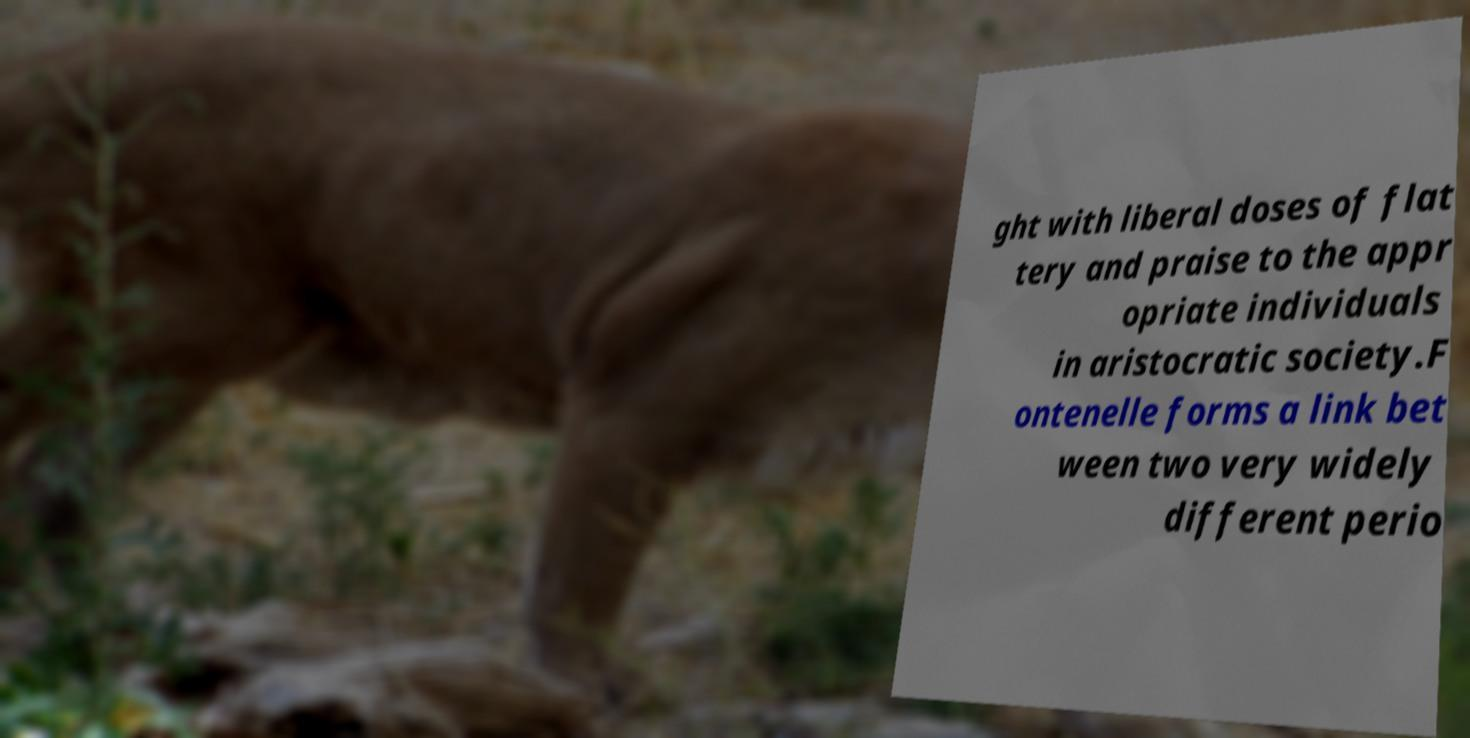Could you extract and type out the text from this image? ght with liberal doses of flat tery and praise to the appr opriate individuals in aristocratic society.F ontenelle forms a link bet ween two very widely different perio 